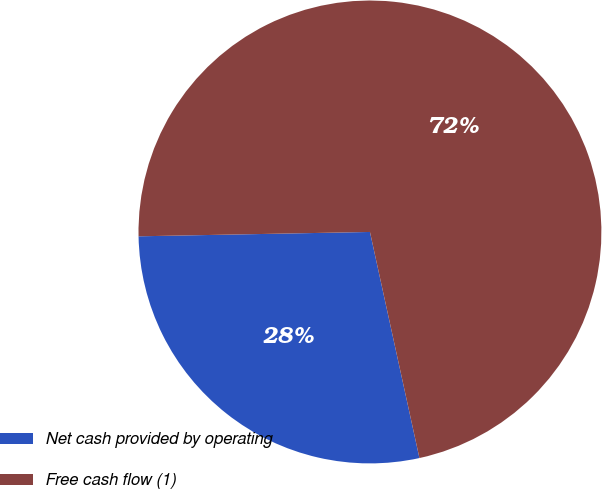<chart> <loc_0><loc_0><loc_500><loc_500><pie_chart><fcel>Net cash provided by operating<fcel>Free cash flow (1)<nl><fcel>28.13%<fcel>71.87%<nl></chart> 